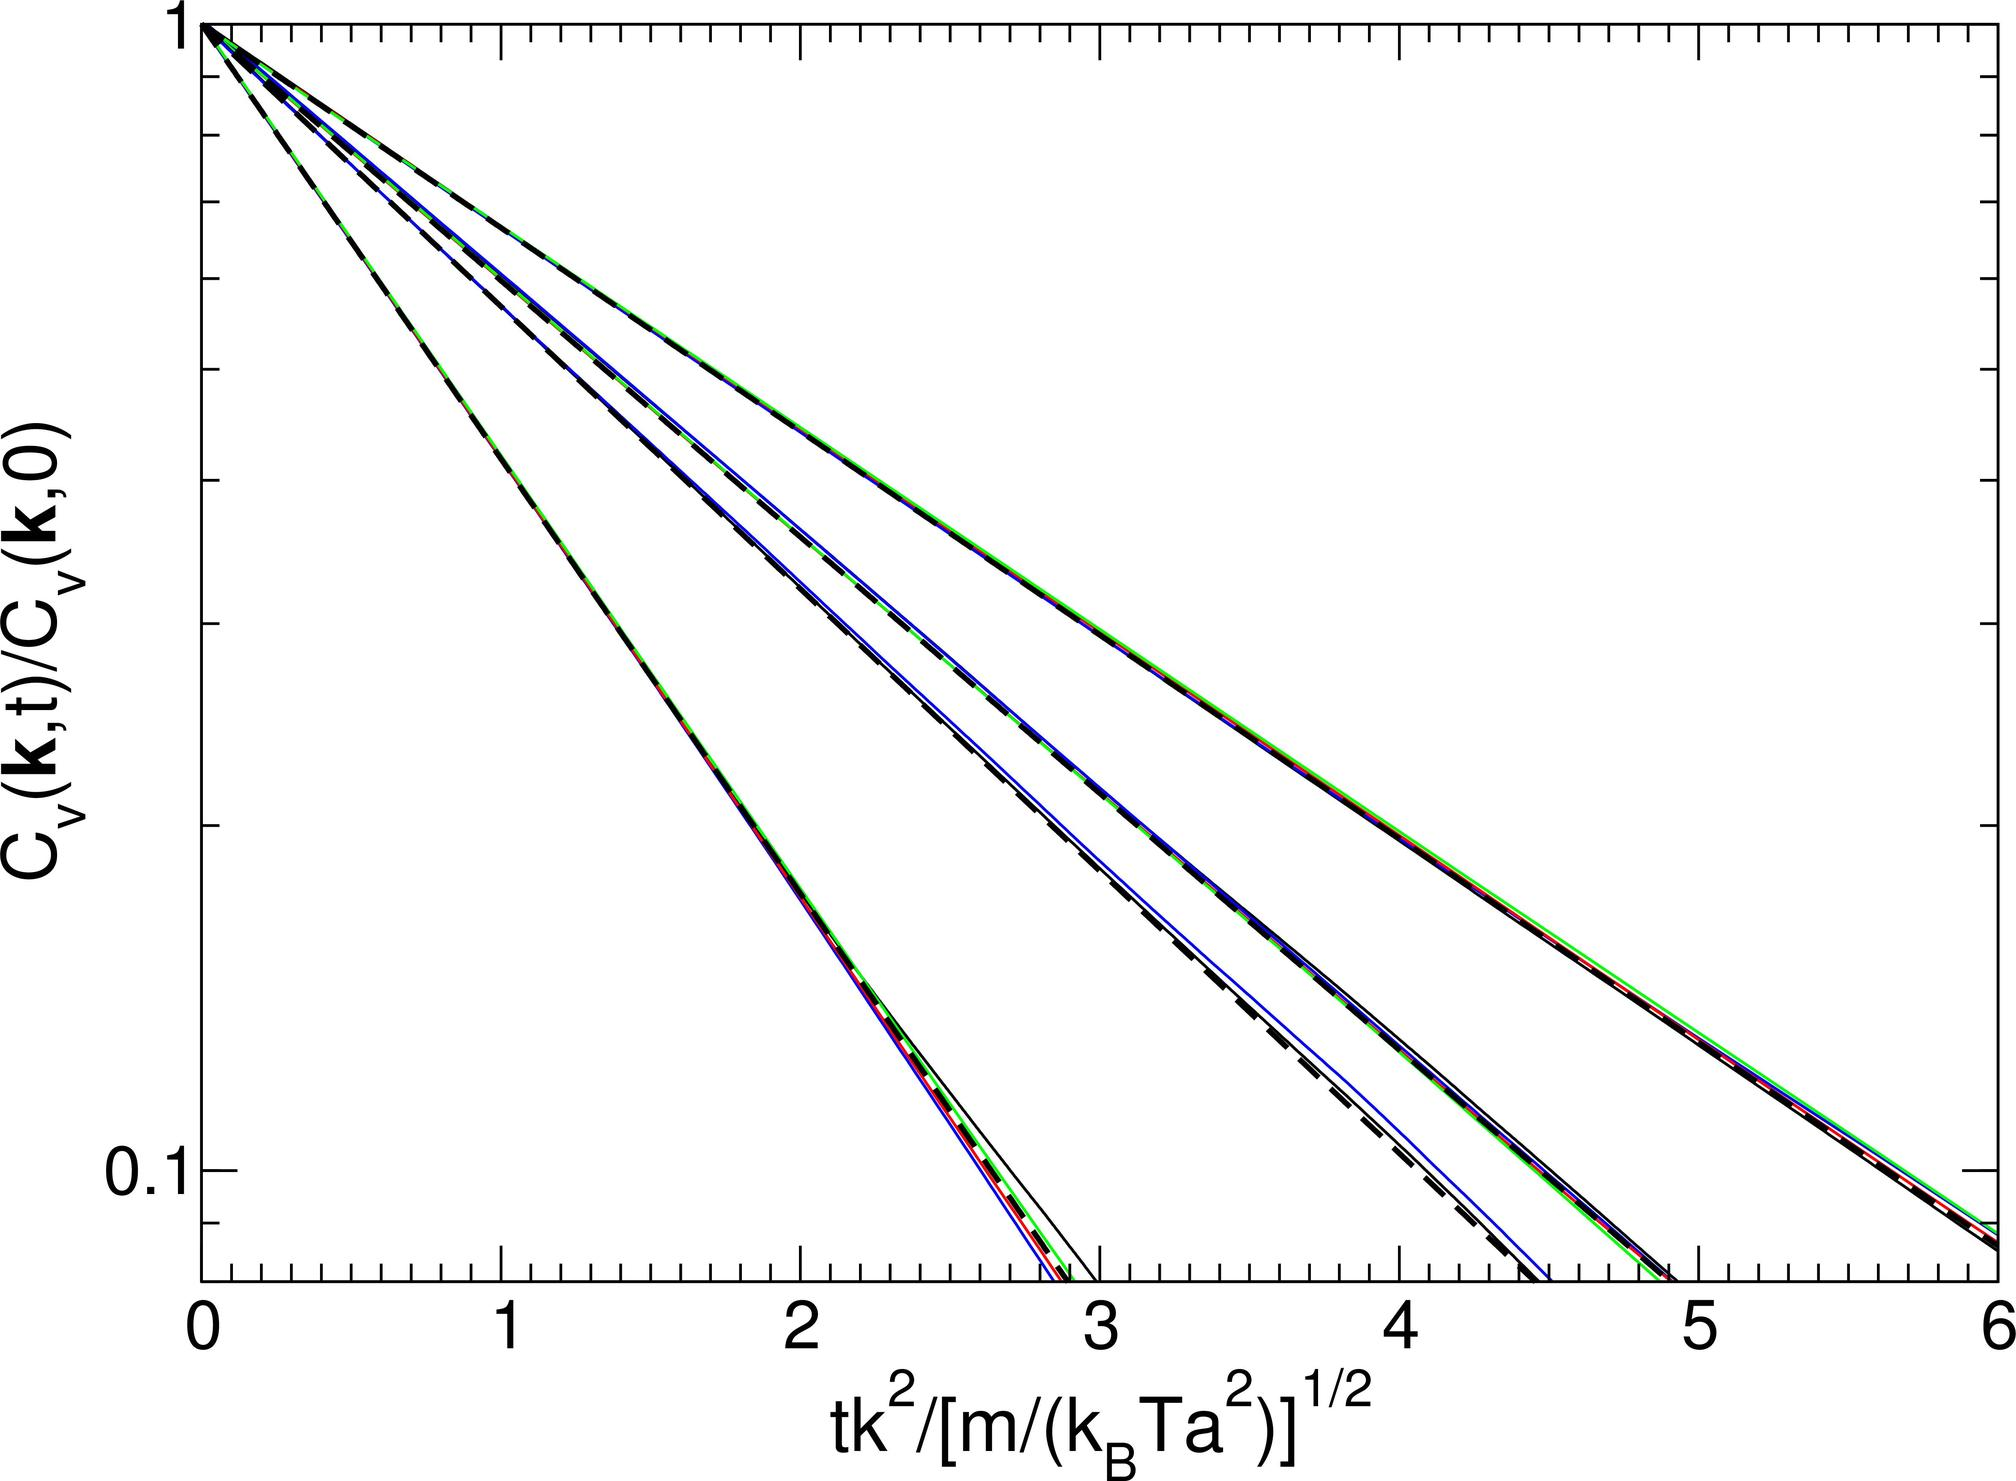What could be the potential impact of varying the parameter \( m \) while keeping \( t \), \( K \), \( k_B \), and \( T_a \) constant based on the graph? A. It would shift the curves toward higher values on the x-axis. B. It would shift the curves toward lower values on the x-axis. C. It would cause the curves to become steeper. D. It would have no effect on the position of the curves. Since \( m \) appears in the denominator inside the square root of the x-axis parameter, increasing \( m \) would increase the denominator, thus requiring a larger value of \( tK^2 \) to achieve the same x-axis value, effectively shifting the curve to the right, toward higher values on the x-axis. Conversely, decreasing \( m \) would shift the curve to the left. Therefore, the correct answer is A. 